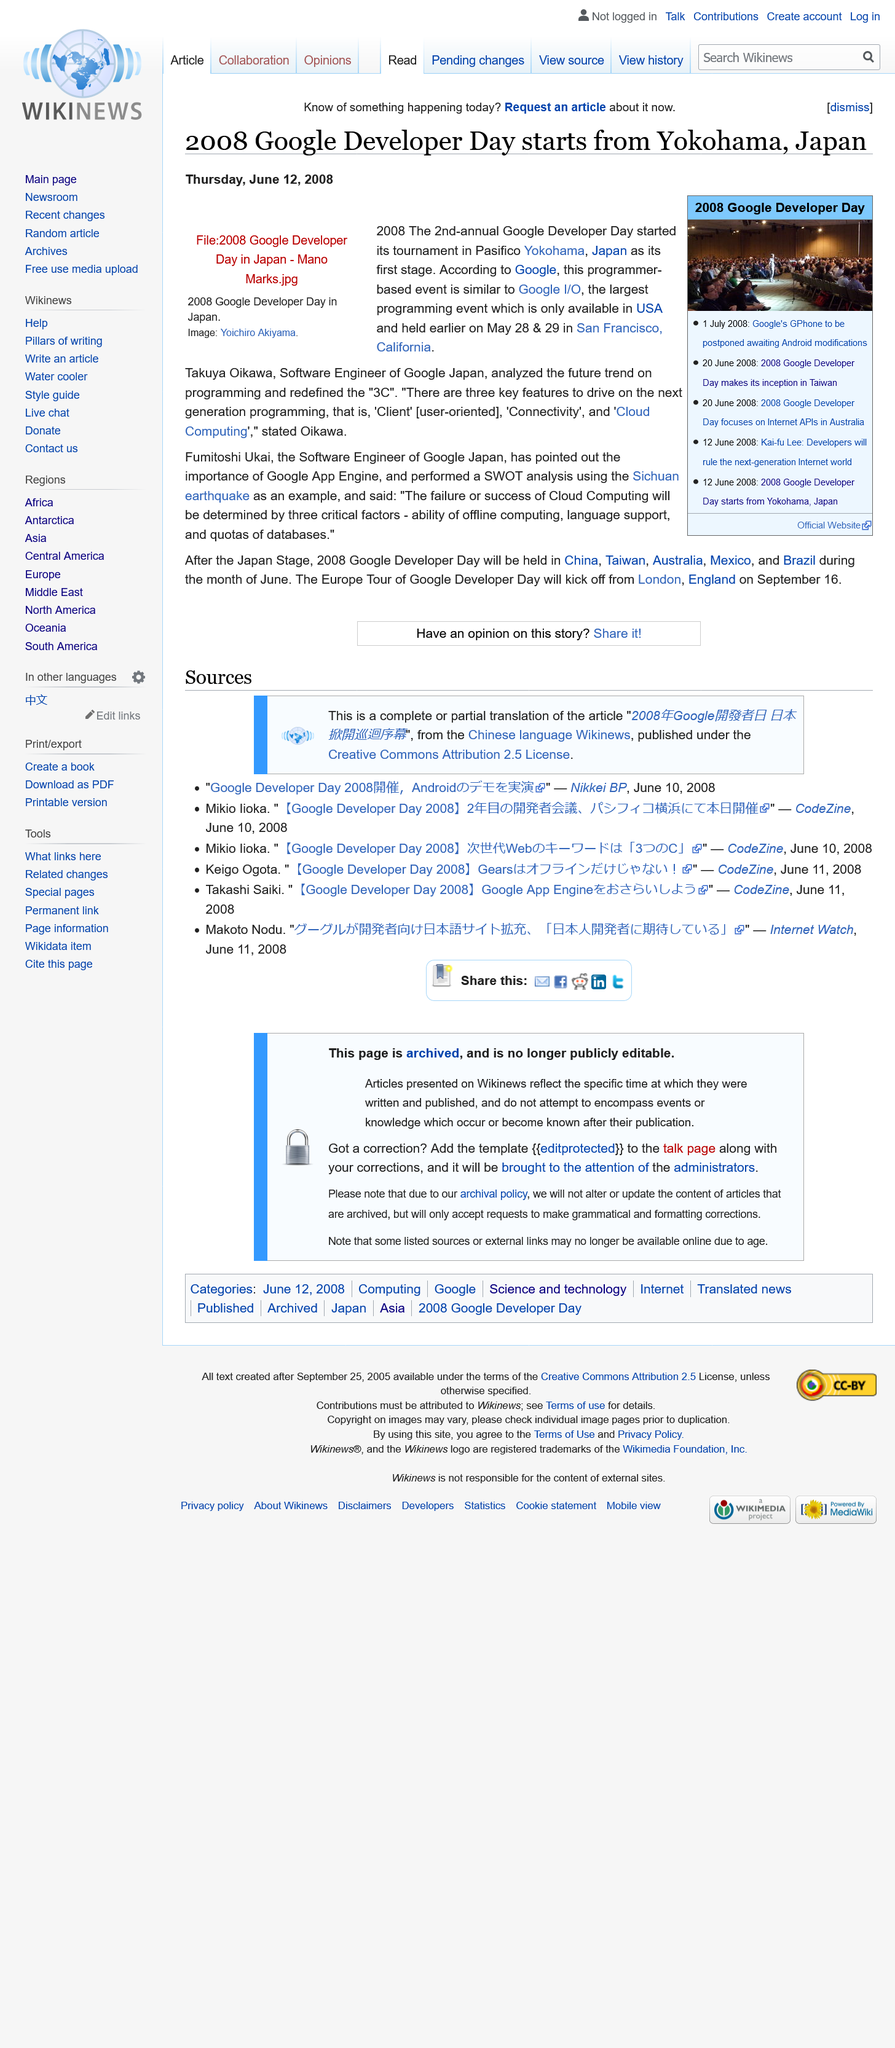Give some essential details in this illustration. The person in the 2008 Google Developer Day image is Yoichiro Akiyama. The Google Developer Day in Japan began on Thursday, June 12, 2008. On June 20, 2008, the focus was on Internet APIs during the Google Developer Day in Australia. 